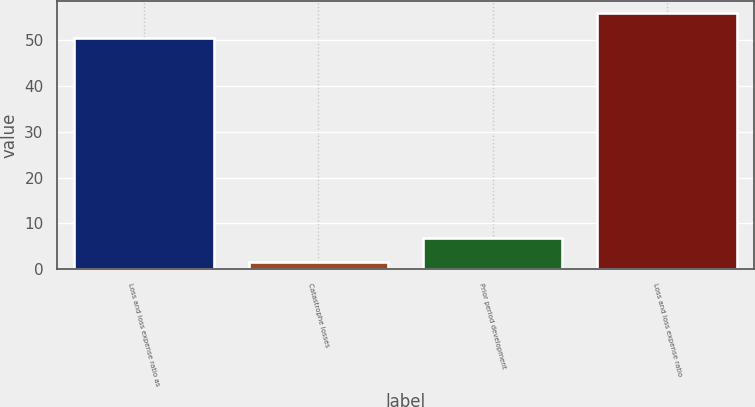Convert chart to OTSL. <chart><loc_0><loc_0><loc_500><loc_500><bar_chart><fcel>Loss and loss expense ratio as<fcel>Catastrophe losses<fcel>Prior period development<fcel>Loss and loss expense ratio<nl><fcel>50.4<fcel>1.6<fcel>6.89<fcel>55.69<nl></chart> 